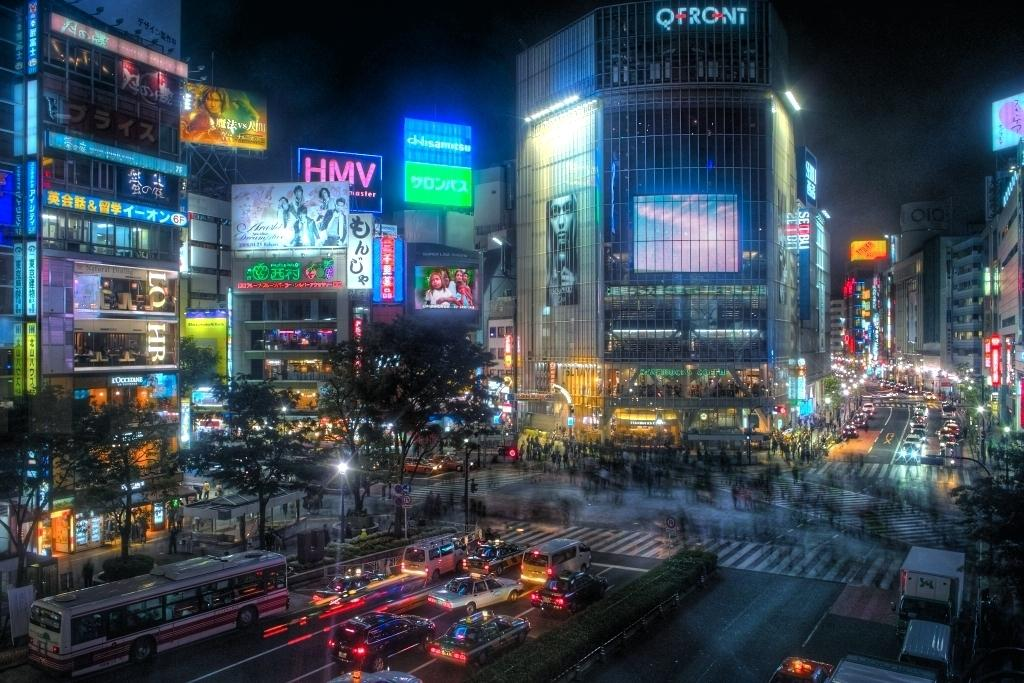What type of structures are depicted in the image? There are buildings with boards and text in the image. What natural elements can be seen in the image? There are trees in the image. What are the people in the image doing? There are people walking on the road in the image. What type of vehicles are present in the image? There are cars in the image. What is visible at the top of the image? The sky is visible at the top of the image. What type of dinner is being served in the image? There is no dinner present in the image; it features buildings, trees, people walking, cars, and the sky. Can you hear the voice of the person in the image? There is no person speaking in the image, so it is not possible to hear their voice. 